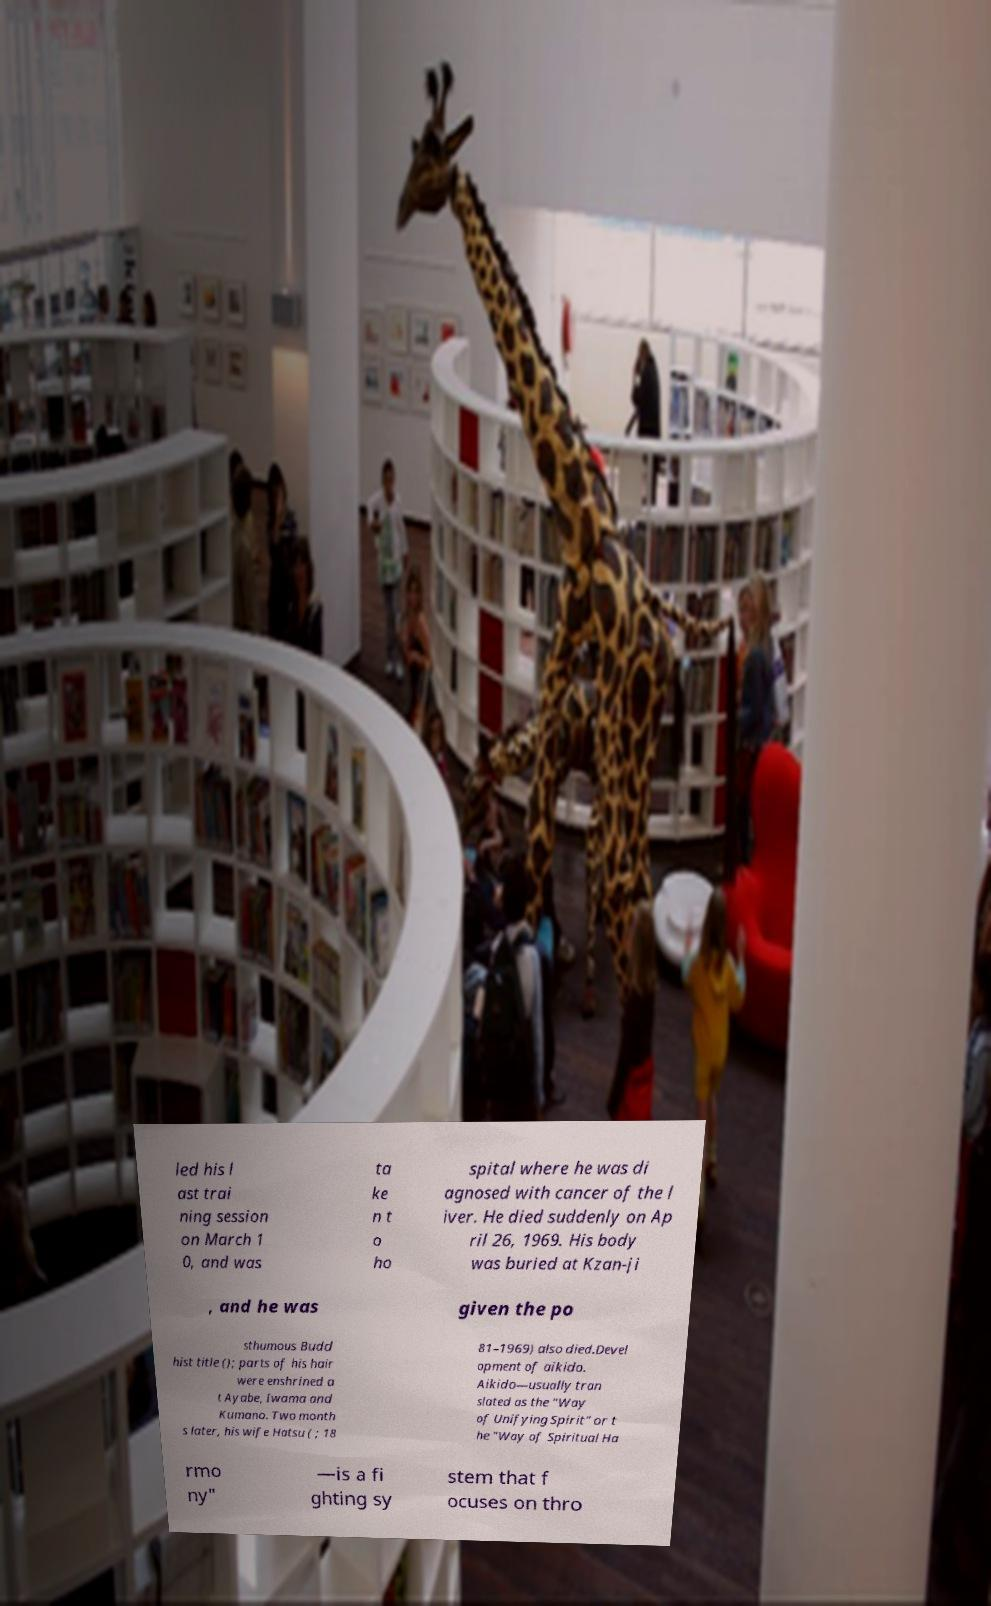There's text embedded in this image that I need extracted. Can you transcribe it verbatim? led his l ast trai ning session on March 1 0, and was ta ke n t o ho spital where he was di agnosed with cancer of the l iver. He died suddenly on Ap ril 26, 1969. His body was buried at Kzan-ji , and he was given the po sthumous Budd hist title (); parts of his hair were enshrined a t Ayabe, Iwama and Kumano. Two month s later, his wife Hatsu ( ; 18 81–1969) also died.Devel opment of aikido. Aikido—usually tran slated as the "Way of Unifying Spirit" or t he "Way of Spiritual Ha rmo ny" —is a fi ghting sy stem that f ocuses on thro 